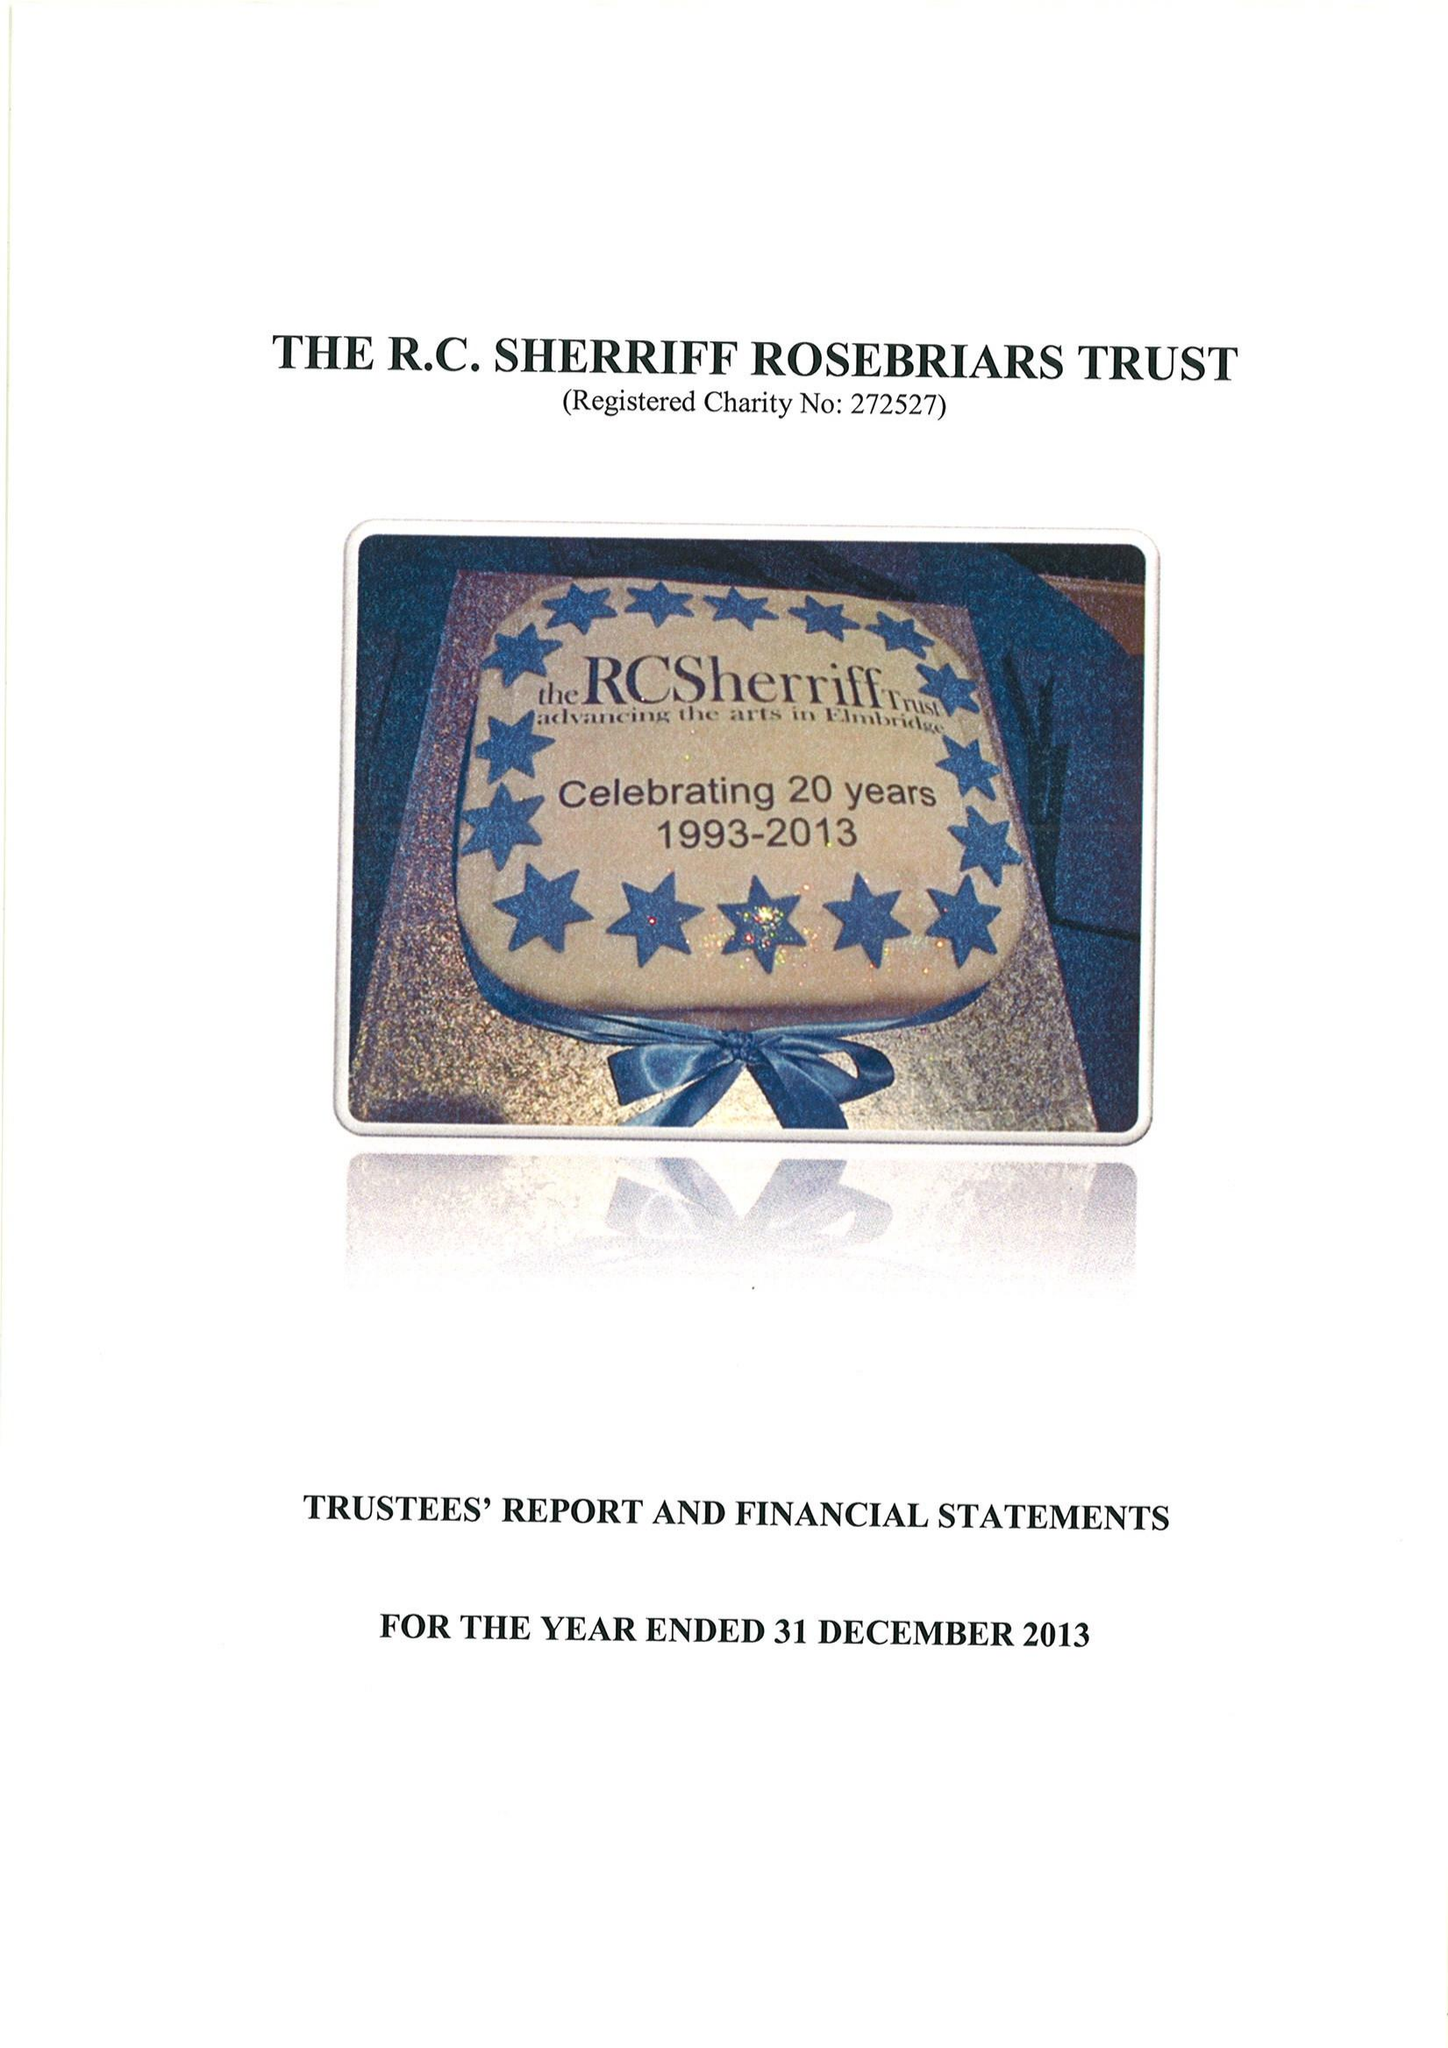What is the value for the charity_number?
Answer the question using a single word or phrase. 272527 